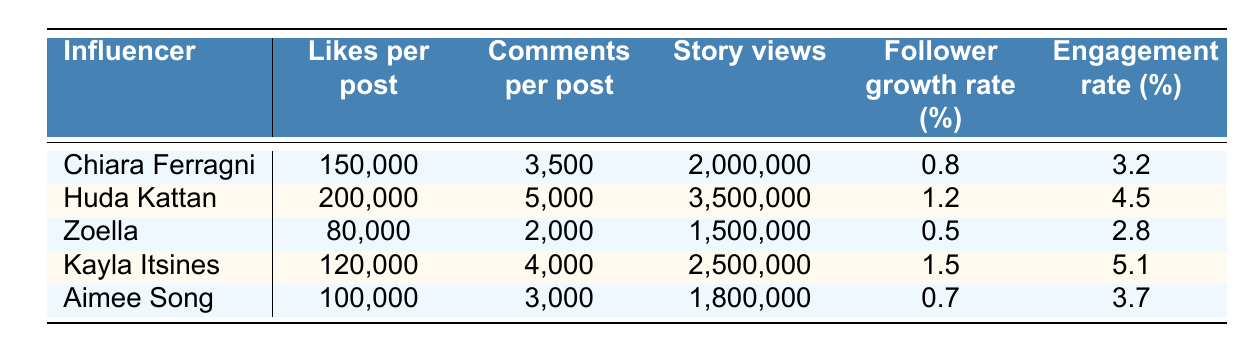What is the highest engagement rate among the influencers? Looking at the "Engagement rate" column, I see that Kayla Itsines has the highest value at 5.1%.
Answer: 5.1% Which influencer has the most story views? From the "Story views" column, Huda Kattan has the highest number with 3,500,000 views.
Answer: 3,500,000 How many likes per post does Chiara Ferragni receive? Referring to the "Likes per post" column, Chiara Ferragni's value is 150,000 likes per post.
Answer: 150,000 What is the average follower growth rate across all influencers? Adding the follower growth rates (0.8 + 1.2 + 0.5 + 1.5 + 0.7 = 4.7), then dividing by 5 gives an average of 0.94%.
Answer: 0.94% Is it true that Zoella has more comments per post than Aimee Song? Comparing the "Comments per post" numbers, Zoella has 2,000 and Aimee Song has 3,000, so Zoella has fewer comments.
Answer: No Which influencer has the lowest likes per post, and what is that value? In the "Likes per post" column, Zoella has the lowest at 80,000 likes per post.
Answer: 80,000 What is the combined total of story views for Kayla Itsines and Aimee Song? Adding Kayla Itsines's story views (2,500,000) and Aimee Song's (1,800,000) results in a total of 4,300,000.
Answer: 4,300,000 How do Chiara Ferragni's comments per post compare to Huda Kattan's? Chiara Ferragni has 3,500 comments per post while Huda Kattan has 5,000, so Chiara Ferragni has fewer comments.
Answer: Fewer What is the difference in engagement rate between Huda Kattan and Kayla Itsines? Huda Kattan's engagement rate is 4.5% and Kayla Itsines' is 5.1%, so the difference is 5.1 - 4.5 = 0.6%.
Answer: 0.6% Which influencer has both the highest follower growth rate and comments per post? Kayla Itsines has the highest follower growth rate at 1.5% and 4,000 comments per post, making her the only one fitting both criteria.
Answer: Kayla Itsines 